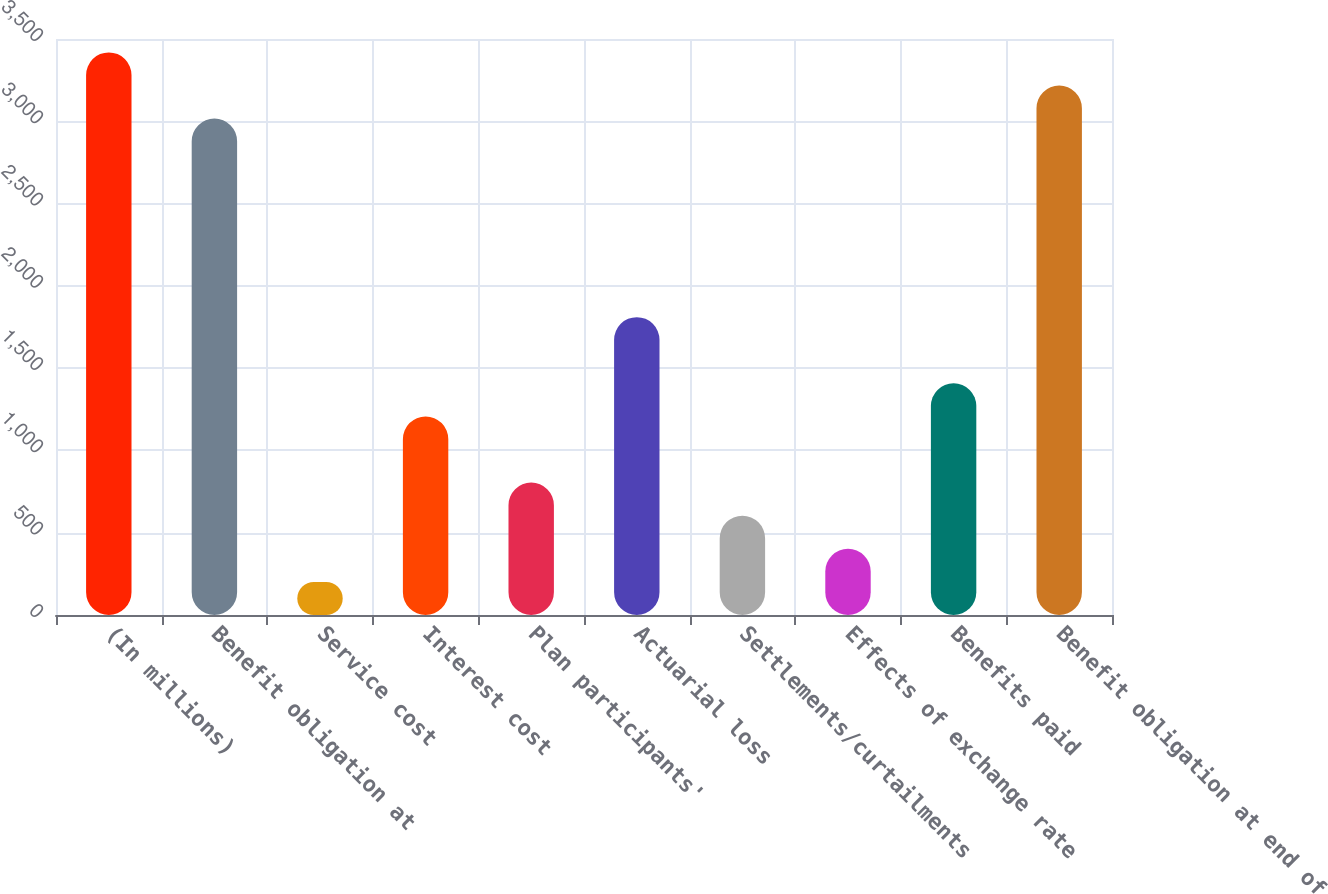Convert chart to OTSL. <chart><loc_0><loc_0><loc_500><loc_500><bar_chart><fcel>(In millions)<fcel>Benefit obligation at<fcel>Service cost<fcel>Interest cost<fcel>Plan participants'<fcel>Actuarial loss<fcel>Settlements/curtailments<fcel>Effects of exchange rate<fcel>Benefits paid<fcel>Benefit obligation at end of<nl><fcel>3418.63<fcel>3016.45<fcel>201.19<fcel>1206.64<fcel>804.46<fcel>1809.91<fcel>603.37<fcel>402.28<fcel>1407.73<fcel>3217.54<nl></chart> 